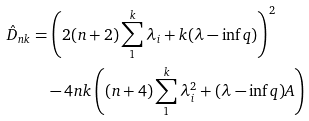Convert formula to latex. <formula><loc_0><loc_0><loc_500><loc_500>\hat { D } _ { n k } & = \left ( 2 ( n + 2 ) \sum _ { 1 } ^ { k } \lambda _ { i } + k ( \lambda - \inf q ) \right ) ^ { 2 } \\ & \quad - 4 n k \left ( ( n + 4 ) \sum _ { 1 } ^ { k } \lambda _ { i } ^ { 2 } + ( \lambda - \inf q ) A \right )</formula> 